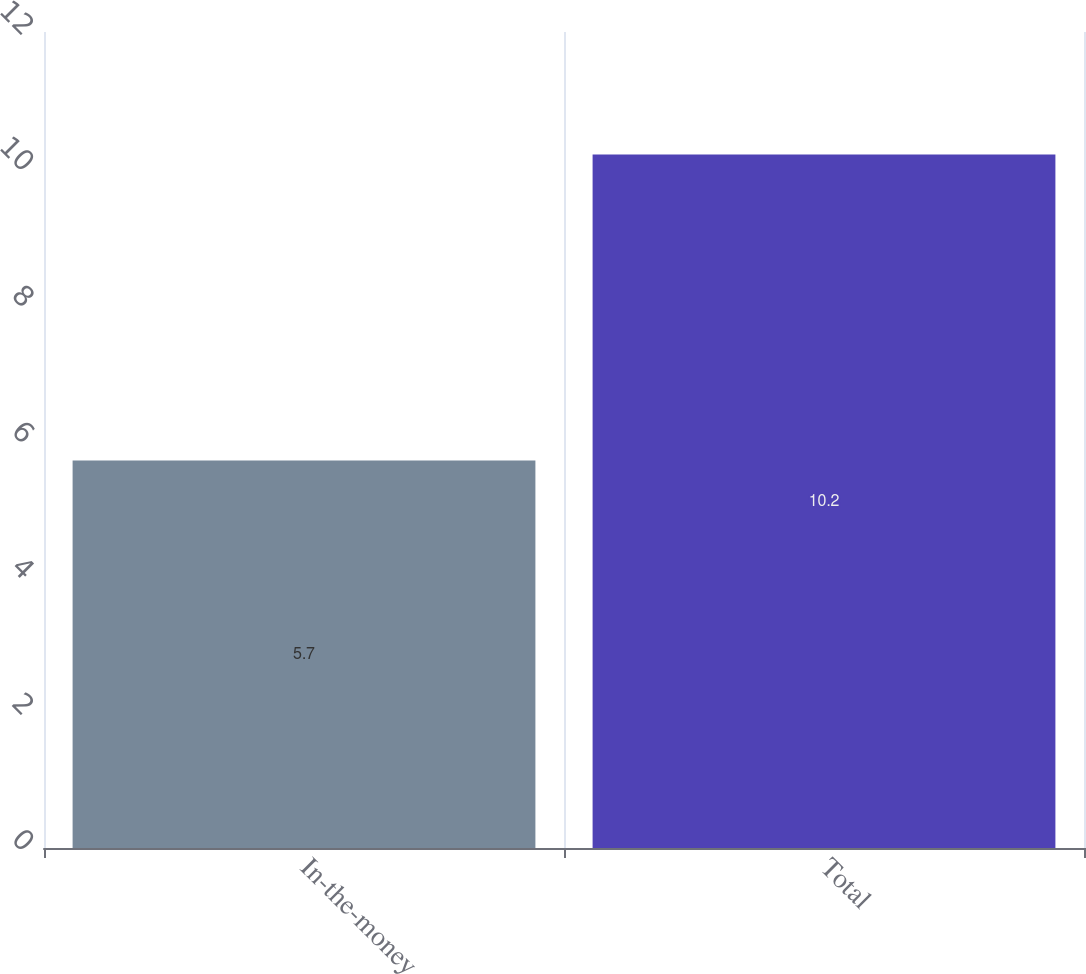<chart> <loc_0><loc_0><loc_500><loc_500><bar_chart><fcel>In-the-money<fcel>Total<nl><fcel>5.7<fcel>10.2<nl></chart> 